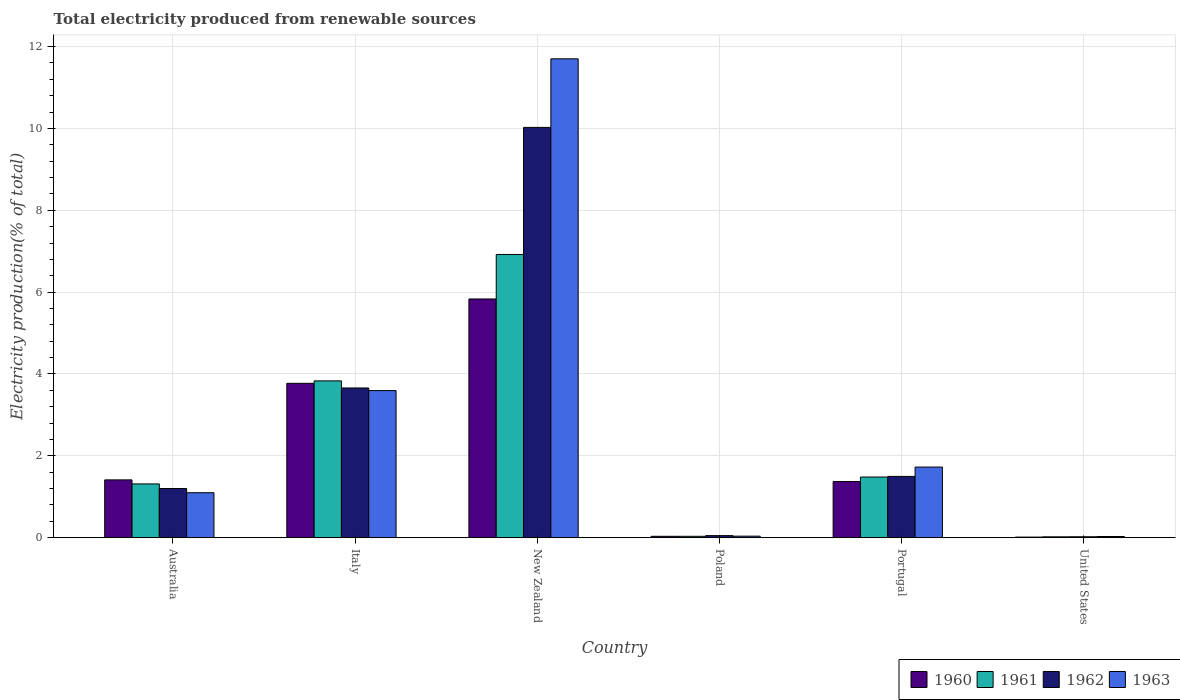How many different coloured bars are there?
Make the answer very short. 4. What is the label of the 3rd group of bars from the left?
Offer a terse response. New Zealand. What is the total electricity produced in 1961 in Italy?
Offer a terse response. 3.83. Across all countries, what is the maximum total electricity produced in 1962?
Your response must be concise. 10.02. Across all countries, what is the minimum total electricity produced in 1960?
Offer a very short reply. 0.02. In which country was the total electricity produced in 1960 maximum?
Offer a terse response. New Zealand. What is the total total electricity produced in 1960 in the graph?
Offer a very short reply. 12.44. What is the difference between the total electricity produced in 1961 in Poland and that in Portugal?
Your response must be concise. -1.45. What is the difference between the total electricity produced in 1961 in Poland and the total electricity produced in 1962 in United States?
Make the answer very short. 0.01. What is the average total electricity produced in 1961 per country?
Make the answer very short. 2.27. What is the difference between the total electricity produced of/in 1961 and total electricity produced of/in 1963 in New Zealand?
Provide a succinct answer. -4.78. In how many countries, is the total electricity produced in 1962 greater than 0.4 %?
Ensure brevity in your answer.  4. What is the ratio of the total electricity produced in 1962 in Poland to that in Portugal?
Offer a terse response. 0.03. Is the total electricity produced in 1960 in Poland less than that in United States?
Provide a succinct answer. No. What is the difference between the highest and the second highest total electricity produced in 1960?
Your response must be concise. -2.36. What is the difference between the highest and the lowest total electricity produced in 1962?
Make the answer very short. 10. What does the 1st bar from the right in Australia represents?
Offer a terse response. 1963. Is it the case that in every country, the sum of the total electricity produced in 1961 and total electricity produced in 1960 is greater than the total electricity produced in 1962?
Give a very brief answer. Yes. How many bars are there?
Keep it short and to the point. 24. Are all the bars in the graph horizontal?
Provide a succinct answer. No. How many countries are there in the graph?
Give a very brief answer. 6. What is the difference between two consecutive major ticks on the Y-axis?
Offer a terse response. 2. Does the graph contain grids?
Provide a succinct answer. Yes. How many legend labels are there?
Offer a very short reply. 4. What is the title of the graph?
Provide a short and direct response. Total electricity produced from renewable sources. What is the label or title of the Y-axis?
Provide a short and direct response. Electricity production(% of total). What is the Electricity production(% of total) of 1960 in Australia?
Provide a short and direct response. 1.41. What is the Electricity production(% of total) of 1961 in Australia?
Provide a succinct answer. 1.31. What is the Electricity production(% of total) of 1962 in Australia?
Keep it short and to the point. 1.2. What is the Electricity production(% of total) in 1963 in Australia?
Provide a short and direct response. 1.1. What is the Electricity production(% of total) of 1960 in Italy?
Ensure brevity in your answer.  3.77. What is the Electricity production(% of total) in 1961 in Italy?
Provide a short and direct response. 3.83. What is the Electricity production(% of total) of 1962 in Italy?
Give a very brief answer. 3.66. What is the Electricity production(% of total) in 1963 in Italy?
Offer a terse response. 3.59. What is the Electricity production(% of total) of 1960 in New Zealand?
Keep it short and to the point. 5.83. What is the Electricity production(% of total) in 1961 in New Zealand?
Your answer should be very brief. 6.92. What is the Electricity production(% of total) of 1962 in New Zealand?
Your answer should be very brief. 10.02. What is the Electricity production(% of total) of 1963 in New Zealand?
Ensure brevity in your answer.  11.7. What is the Electricity production(% of total) in 1960 in Poland?
Offer a very short reply. 0.03. What is the Electricity production(% of total) in 1961 in Poland?
Your response must be concise. 0.03. What is the Electricity production(% of total) in 1962 in Poland?
Make the answer very short. 0.05. What is the Electricity production(% of total) of 1963 in Poland?
Give a very brief answer. 0.04. What is the Electricity production(% of total) in 1960 in Portugal?
Your answer should be compact. 1.37. What is the Electricity production(% of total) of 1961 in Portugal?
Offer a terse response. 1.48. What is the Electricity production(% of total) in 1962 in Portugal?
Provide a short and direct response. 1.5. What is the Electricity production(% of total) of 1963 in Portugal?
Provide a short and direct response. 1.73. What is the Electricity production(% of total) of 1960 in United States?
Make the answer very short. 0.02. What is the Electricity production(% of total) in 1961 in United States?
Provide a succinct answer. 0.02. What is the Electricity production(% of total) in 1962 in United States?
Offer a terse response. 0.02. What is the Electricity production(% of total) of 1963 in United States?
Make the answer very short. 0.03. Across all countries, what is the maximum Electricity production(% of total) of 1960?
Provide a short and direct response. 5.83. Across all countries, what is the maximum Electricity production(% of total) of 1961?
Offer a very short reply. 6.92. Across all countries, what is the maximum Electricity production(% of total) in 1962?
Offer a very short reply. 10.02. Across all countries, what is the maximum Electricity production(% of total) in 1963?
Offer a terse response. 11.7. Across all countries, what is the minimum Electricity production(% of total) of 1960?
Your answer should be very brief. 0.02. Across all countries, what is the minimum Electricity production(% of total) in 1961?
Your response must be concise. 0.02. Across all countries, what is the minimum Electricity production(% of total) in 1962?
Offer a terse response. 0.02. Across all countries, what is the minimum Electricity production(% of total) in 1963?
Ensure brevity in your answer.  0.03. What is the total Electricity production(% of total) of 1960 in the graph?
Provide a succinct answer. 12.44. What is the total Electricity production(% of total) of 1961 in the graph?
Give a very brief answer. 13.6. What is the total Electricity production(% of total) of 1962 in the graph?
Offer a very short reply. 16.46. What is the total Electricity production(% of total) of 1963 in the graph?
Your answer should be very brief. 18.19. What is the difference between the Electricity production(% of total) in 1960 in Australia and that in Italy?
Your response must be concise. -2.36. What is the difference between the Electricity production(% of total) in 1961 in Australia and that in Italy?
Make the answer very short. -2.52. What is the difference between the Electricity production(% of total) of 1962 in Australia and that in Italy?
Offer a very short reply. -2.46. What is the difference between the Electricity production(% of total) of 1963 in Australia and that in Italy?
Offer a terse response. -2.5. What is the difference between the Electricity production(% of total) in 1960 in Australia and that in New Zealand?
Offer a terse response. -4.42. What is the difference between the Electricity production(% of total) in 1961 in Australia and that in New Zealand?
Offer a very short reply. -5.61. What is the difference between the Electricity production(% of total) in 1962 in Australia and that in New Zealand?
Offer a terse response. -8.82. What is the difference between the Electricity production(% of total) of 1963 in Australia and that in New Zealand?
Offer a very short reply. -10.6. What is the difference between the Electricity production(% of total) in 1960 in Australia and that in Poland?
Your answer should be very brief. 1.38. What is the difference between the Electricity production(% of total) of 1961 in Australia and that in Poland?
Your answer should be compact. 1.28. What is the difference between the Electricity production(% of total) of 1962 in Australia and that in Poland?
Provide a short and direct response. 1.15. What is the difference between the Electricity production(% of total) of 1963 in Australia and that in Poland?
Provide a succinct answer. 1.06. What is the difference between the Electricity production(% of total) in 1960 in Australia and that in Portugal?
Offer a terse response. 0.04. What is the difference between the Electricity production(% of total) in 1961 in Australia and that in Portugal?
Provide a short and direct response. -0.17. What is the difference between the Electricity production(% of total) in 1962 in Australia and that in Portugal?
Your response must be concise. -0.3. What is the difference between the Electricity production(% of total) of 1963 in Australia and that in Portugal?
Ensure brevity in your answer.  -0.63. What is the difference between the Electricity production(% of total) of 1960 in Australia and that in United States?
Your answer should be compact. 1.4. What is the difference between the Electricity production(% of total) in 1961 in Australia and that in United States?
Your response must be concise. 1.29. What is the difference between the Electricity production(% of total) in 1962 in Australia and that in United States?
Keep it short and to the point. 1.18. What is the difference between the Electricity production(% of total) of 1963 in Australia and that in United States?
Provide a succinct answer. 1.07. What is the difference between the Electricity production(% of total) in 1960 in Italy and that in New Zealand?
Your answer should be very brief. -2.06. What is the difference between the Electricity production(% of total) in 1961 in Italy and that in New Zealand?
Your answer should be very brief. -3.09. What is the difference between the Electricity production(% of total) in 1962 in Italy and that in New Zealand?
Make the answer very short. -6.37. What is the difference between the Electricity production(% of total) of 1963 in Italy and that in New Zealand?
Your response must be concise. -8.11. What is the difference between the Electricity production(% of total) of 1960 in Italy and that in Poland?
Give a very brief answer. 3.74. What is the difference between the Electricity production(% of total) of 1961 in Italy and that in Poland?
Your answer should be compact. 3.8. What is the difference between the Electricity production(% of total) in 1962 in Italy and that in Poland?
Provide a short and direct response. 3.61. What is the difference between the Electricity production(% of total) in 1963 in Italy and that in Poland?
Offer a terse response. 3.56. What is the difference between the Electricity production(% of total) in 1960 in Italy and that in Portugal?
Make the answer very short. 2.4. What is the difference between the Electricity production(% of total) of 1961 in Italy and that in Portugal?
Keep it short and to the point. 2.35. What is the difference between the Electricity production(% of total) of 1962 in Italy and that in Portugal?
Provide a short and direct response. 2.16. What is the difference between the Electricity production(% of total) in 1963 in Italy and that in Portugal?
Keep it short and to the point. 1.87. What is the difference between the Electricity production(% of total) of 1960 in Italy and that in United States?
Provide a short and direct response. 3.76. What is the difference between the Electricity production(% of total) in 1961 in Italy and that in United States?
Keep it short and to the point. 3.81. What is the difference between the Electricity production(% of total) of 1962 in Italy and that in United States?
Provide a short and direct response. 3.64. What is the difference between the Electricity production(% of total) of 1963 in Italy and that in United States?
Keep it short and to the point. 3.56. What is the difference between the Electricity production(% of total) of 1960 in New Zealand and that in Poland?
Offer a terse response. 5.8. What is the difference between the Electricity production(% of total) of 1961 in New Zealand and that in Poland?
Make the answer very short. 6.89. What is the difference between the Electricity production(% of total) in 1962 in New Zealand and that in Poland?
Your response must be concise. 9.97. What is the difference between the Electricity production(% of total) in 1963 in New Zealand and that in Poland?
Provide a short and direct response. 11.66. What is the difference between the Electricity production(% of total) of 1960 in New Zealand and that in Portugal?
Provide a succinct answer. 4.46. What is the difference between the Electricity production(% of total) in 1961 in New Zealand and that in Portugal?
Your answer should be compact. 5.44. What is the difference between the Electricity production(% of total) in 1962 in New Zealand and that in Portugal?
Give a very brief answer. 8.53. What is the difference between the Electricity production(% of total) in 1963 in New Zealand and that in Portugal?
Your answer should be compact. 9.97. What is the difference between the Electricity production(% of total) of 1960 in New Zealand and that in United States?
Provide a short and direct response. 5.82. What is the difference between the Electricity production(% of total) in 1961 in New Zealand and that in United States?
Offer a terse response. 6.9. What is the difference between the Electricity production(% of total) of 1962 in New Zealand and that in United States?
Keep it short and to the point. 10. What is the difference between the Electricity production(% of total) of 1963 in New Zealand and that in United States?
Give a very brief answer. 11.67. What is the difference between the Electricity production(% of total) in 1960 in Poland and that in Portugal?
Your response must be concise. -1.34. What is the difference between the Electricity production(% of total) in 1961 in Poland and that in Portugal?
Offer a very short reply. -1.45. What is the difference between the Electricity production(% of total) in 1962 in Poland and that in Portugal?
Provide a succinct answer. -1.45. What is the difference between the Electricity production(% of total) in 1963 in Poland and that in Portugal?
Your answer should be compact. -1.69. What is the difference between the Electricity production(% of total) in 1960 in Poland and that in United States?
Offer a terse response. 0.02. What is the difference between the Electricity production(% of total) in 1961 in Poland and that in United States?
Offer a very short reply. 0.01. What is the difference between the Electricity production(% of total) of 1962 in Poland and that in United States?
Provide a succinct answer. 0.03. What is the difference between the Electricity production(% of total) of 1963 in Poland and that in United States?
Keep it short and to the point. 0.01. What is the difference between the Electricity production(% of total) in 1960 in Portugal and that in United States?
Your answer should be very brief. 1.36. What is the difference between the Electricity production(% of total) in 1961 in Portugal and that in United States?
Ensure brevity in your answer.  1.46. What is the difference between the Electricity production(% of total) in 1962 in Portugal and that in United States?
Provide a succinct answer. 1.48. What is the difference between the Electricity production(% of total) of 1963 in Portugal and that in United States?
Give a very brief answer. 1.7. What is the difference between the Electricity production(% of total) of 1960 in Australia and the Electricity production(% of total) of 1961 in Italy?
Offer a terse response. -2.42. What is the difference between the Electricity production(% of total) in 1960 in Australia and the Electricity production(% of total) in 1962 in Italy?
Make the answer very short. -2.25. What is the difference between the Electricity production(% of total) of 1960 in Australia and the Electricity production(% of total) of 1963 in Italy?
Your answer should be very brief. -2.18. What is the difference between the Electricity production(% of total) of 1961 in Australia and the Electricity production(% of total) of 1962 in Italy?
Your response must be concise. -2.34. What is the difference between the Electricity production(% of total) in 1961 in Australia and the Electricity production(% of total) in 1963 in Italy?
Keep it short and to the point. -2.28. What is the difference between the Electricity production(% of total) of 1962 in Australia and the Electricity production(% of total) of 1963 in Italy?
Offer a terse response. -2.39. What is the difference between the Electricity production(% of total) of 1960 in Australia and the Electricity production(% of total) of 1961 in New Zealand?
Keep it short and to the point. -5.51. What is the difference between the Electricity production(% of total) in 1960 in Australia and the Electricity production(% of total) in 1962 in New Zealand?
Provide a short and direct response. -8.61. What is the difference between the Electricity production(% of total) of 1960 in Australia and the Electricity production(% of total) of 1963 in New Zealand?
Your answer should be very brief. -10.29. What is the difference between the Electricity production(% of total) of 1961 in Australia and the Electricity production(% of total) of 1962 in New Zealand?
Make the answer very short. -8.71. What is the difference between the Electricity production(% of total) of 1961 in Australia and the Electricity production(% of total) of 1963 in New Zealand?
Offer a very short reply. -10.39. What is the difference between the Electricity production(% of total) of 1962 in Australia and the Electricity production(% of total) of 1963 in New Zealand?
Your response must be concise. -10.5. What is the difference between the Electricity production(% of total) in 1960 in Australia and the Electricity production(% of total) in 1961 in Poland?
Provide a succinct answer. 1.38. What is the difference between the Electricity production(% of total) in 1960 in Australia and the Electricity production(% of total) in 1962 in Poland?
Your answer should be compact. 1.36. What is the difference between the Electricity production(% of total) of 1960 in Australia and the Electricity production(% of total) of 1963 in Poland?
Ensure brevity in your answer.  1.37. What is the difference between the Electricity production(% of total) in 1961 in Australia and the Electricity production(% of total) in 1962 in Poland?
Offer a very short reply. 1.26. What is the difference between the Electricity production(% of total) in 1961 in Australia and the Electricity production(% of total) in 1963 in Poland?
Offer a very short reply. 1.28. What is the difference between the Electricity production(% of total) of 1962 in Australia and the Electricity production(% of total) of 1963 in Poland?
Offer a terse response. 1.16. What is the difference between the Electricity production(% of total) in 1960 in Australia and the Electricity production(% of total) in 1961 in Portugal?
Keep it short and to the point. -0.07. What is the difference between the Electricity production(% of total) in 1960 in Australia and the Electricity production(% of total) in 1962 in Portugal?
Ensure brevity in your answer.  -0.09. What is the difference between the Electricity production(% of total) of 1960 in Australia and the Electricity production(% of total) of 1963 in Portugal?
Your answer should be compact. -0.31. What is the difference between the Electricity production(% of total) in 1961 in Australia and the Electricity production(% of total) in 1962 in Portugal?
Offer a terse response. -0.18. What is the difference between the Electricity production(% of total) in 1961 in Australia and the Electricity production(% of total) in 1963 in Portugal?
Give a very brief answer. -0.41. What is the difference between the Electricity production(% of total) in 1962 in Australia and the Electricity production(% of total) in 1963 in Portugal?
Offer a terse response. -0.52. What is the difference between the Electricity production(% of total) in 1960 in Australia and the Electricity production(% of total) in 1961 in United States?
Your answer should be compact. 1.39. What is the difference between the Electricity production(% of total) of 1960 in Australia and the Electricity production(% of total) of 1962 in United States?
Provide a succinct answer. 1.39. What is the difference between the Electricity production(% of total) in 1960 in Australia and the Electricity production(% of total) in 1963 in United States?
Provide a succinct answer. 1.38. What is the difference between the Electricity production(% of total) in 1961 in Australia and the Electricity production(% of total) in 1962 in United States?
Keep it short and to the point. 1.29. What is the difference between the Electricity production(% of total) of 1961 in Australia and the Electricity production(% of total) of 1963 in United States?
Give a very brief answer. 1.28. What is the difference between the Electricity production(% of total) of 1962 in Australia and the Electricity production(% of total) of 1963 in United States?
Your answer should be very brief. 1.17. What is the difference between the Electricity production(% of total) in 1960 in Italy and the Electricity production(% of total) in 1961 in New Zealand?
Provide a short and direct response. -3.15. What is the difference between the Electricity production(% of total) in 1960 in Italy and the Electricity production(% of total) in 1962 in New Zealand?
Your response must be concise. -6.25. What is the difference between the Electricity production(% of total) of 1960 in Italy and the Electricity production(% of total) of 1963 in New Zealand?
Your response must be concise. -7.93. What is the difference between the Electricity production(% of total) in 1961 in Italy and the Electricity production(% of total) in 1962 in New Zealand?
Offer a very short reply. -6.19. What is the difference between the Electricity production(% of total) in 1961 in Italy and the Electricity production(% of total) in 1963 in New Zealand?
Give a very brief answer. -7.87. What is the difference between the Electricity production(% of total) in 1962 in Italy and the Electricity production(% of total) in 1963 in New Zealand?
Your answer should be compact. -8.04. What is the difference between the Electricity production(% of total) of 1960 in Italy and the Electricity production(% of total) of 1961 in Poland?
Your answer should be very brief. 3.74. What is the difference between the Electricity production(% of total) in 1960 in Italy and the Electricity production(% of total) in 1962 in Poland?
Your response must be concise. 3.72. What is the difference between the Electricity production(% of total) of 1960 in Italy and the Electricity production(% of total) of 1963 in Poland?
Make the answer very short. 3.73. What is the difference between the Electricity production(% of total) in 1961 in Italy and the Electricity production(% of total) in 1962 in Poland?
Offer a very short reply. 3.78. What is the difference between the Electricity production(% of total) in 1961 in Italy and the Electricity production(% of total) in 1963 in Poland?
Ensure brevity in your answer.  3.79. What is the difference between the Electricity production(% of total) of 1962 in Italy and the Electricity production(% of total) of 1963 in Poland?
Keep it short and to the point. 3.62. What is the difference between the Electricity production(% of total) in 1960 in Italy and the Electricity production(% of total) in 1961 in Portugal?
Offer a very short reply. 2.29. What is the difference between the Electricity production(% of total) of 1960 in Italy and the Electricity production(% of total) of 1962 in Portugal?
Offer a very short reply. 2.27. What is the difference between the Electricity production(% of total) of 1960 in Italy and the Electricity production(% of total) of 1963 in Portugal?
Make the answer very short. 2.05. What is the difference between the Electricity production(% of total) of 1961 in Italy and the Electricity production(% of total) of 1962 in Portugal?
Give a very brief answer. 2.33. What is the difference between the Electricity production(% of total) in 1961 in Italy and the Electricity production(% of total) in 1963 in Portugal?
Your response must be concise. 2.11. What is the difference between the Electricity production(% of total) of 1962 in Italy and the Electricity production(% of total) of 1963 in Portugal?
Ensure brevity in your answer.  1.93. What is the difference between the Electricity production(% of total) of 1960 in Italy and the Electricity production(% of total) of 1961 in United States?
Your response must be concise. 3.75. What is the difference between the Electricity production(% of total) of 1960 in Italy and the Electricity production(% of total) of 1962 in United States?
Make the answer very short. 3.75. What is the difference between the Electricity production(% of total) in 1960 in Italy and the Electricity production(% of total) in 1963 in United States?
Provide a succinct answer. 3.74. What is the difference between the Electricity production(% of total) in 1961 in Italy and the Electricity production(% of total) in 1962 in United States?
Your response must be concise. 3.81. What is the difference between the Electricity production(% of total) of 1961 in Italy and the Electricity production(% of total) of 1963 in United States?
Make the answer very short. 3.8. What is the difference between the Electricity production(% of total) in 1962 in Italy and the Electricity production(% of total) in 1963 in United States?
Make the answer very short. 3.63. What is the difference between the Electricity production(% of total) of 1960 in New Zealand and the Electricity production(% of total) of 1961 in Poland?
Give a very brief answer. 5.8. What is the difference between the Electricity production(% of total) of 1960 in New Zealand and the Electricity production(% of total) of 1962 in Poland?
Offer a terse response. 5.78. What is the difference between the Electricity production(% of total) in 1960 in New Zealand and the Electricity production(% of total) in 1963 in Poland?
Make the answer very short. 5.79. What is the difference between the Electricity production(% of total) in 1961 in New Zealand and the Electricity production(% of total) in 1962 in Poland?
Your answer should be very brief. 6.87. What is the difference between the Electricity production(% of total) of 1961 in New Zealand and the Electricity production(% of total) of 1963 in Poland?
Provide a short and direct response. 6.88. What is the difference between the Electricity production(% of total) in 1962 in New Zealand and the Electricity production(% of total) in 1963 in Poland?
Provide a short and direct response. 9.99. What is the difference between the Electricity production(% of total) of 1960 in New Zealand and the Electricity production(% of total) of 1961 in Portugal?
Provide a short and direct response. 4.35. What is the difference between the Electricity production(% of total) of 1960 in New Zealand and the Electricity production(% of total) of 1962 in Portugal?
Offer a very short reply. 4.33. What is the difference between the Electricity production(% of total) of 1960 in New Zealand and the Electricity production(% of total) of 1963 in Portugal?
Your answer should be very brief. 4.11. What is the difference between the Electricity production(% of total) of 1961 in New Zealand and the Electricity production(% of total) of 1962 in Portugal?
Your response must be concise. 5.42. What is the difference between the Electricity production(% of total) of 1961 in New Zealand and the Electricity production(% of total) of 1963 in Portugal?
Make the answer very short. 5.19. What is the difference between the Electricity production(% of total) in 1962 in New Zealand and the Electricity production(% of total) in 1963 in Portugal?
Give a very brief answer. 8.3. What is the difference between the Electricity production(% of total) in 1960 in New Zealand and the Electricity production(% of total) in 1961 in United States?
Provide a succinct answer. 5.81. What is the difference between the Electricity production(% of total) of 1960 in New Zealand and the Electricity production(% of total) of 1962 in United States?
Make the answer very short. 5.81. What is the difference between the Electricity production(% of total) of 1960 in New Zealand and the Electricity production(% of total) of 1963 in United States?
Give a very brief answer. 5.8. What is the difference between the Electricity production(% of total) of 1961 in New Zealand and the Electricity production(% of total) of 1962 in United States?
Ensure brevity in your answer.  6.9. What is the difference between the Electricity production(% of total) in 1961 in New Zealand and the Electricity production(% of total) in 1963 in United States?
Give a very brief answer. 6.89. What is the difference between the Electricity production(% of total) of 1962 in New Zealand and the Electricity production(% of total) of 1963 in United States?
Give a very brief answer. 10. What is the difference between the Electricity production(% of total) of 1960 in Poland and the Electricity production(% of total) of 1961 in Portugal?
Ensure brevity in your answer.  -1.45. What is the difference between the Electricity production(% of total) in 1960 in Poland and the Electricity production(% of total) in 1962 in Portugal?
Keep it short and to the point. -1.46. What is the difference between the Electricity production(% of total) in 1960 in Poland and the Electricity production(% of total) in 1963 in Portugal?
Provide a succinct answer. -1.69. What is the difference between the Electricity production(% of total) of 1961 in Poland and the Electricity production(% of total) of 1962 in Portugal?
Provide a succinct answer. -1.46. What is the difference between the Electricity production(% of total) of 1961 in Poland and the Electricity production(% of total) of 1963 in Portugal?
Offer a very short reply. -1.69. What is the difference between the Electricity production(% of total) in 1962 in Poland and the Electricity production(% of total) in 1963 in Portugal?
Offer a terse response. -1.67. What is the difference between the Electricity production(% of total) in 1960 in Poland and the Electricity production(% of total) in 1961 in United States?
Provide a succinct answer. 0.01. What is the difference between the Electricity production(% of total) in 1960 in Poland and the Electricity production(% of total) in 1962 in United States?
Offer a very short reply. 0.01. What is the difference between the Electricity production(% of total) of 1960 in Poland and the Electricity production(% of total) of 1963 in United States?
Ensure brevity in your answer.  0. What is the difference between the Electricity production(% of total) in 1961 in Poland and the Electricity production(% of total) in 1962 in United States?
Offer a terse response. 0.01. What is the difference between the Electricity production(% of total) in 1961 in Poland and the Electricity production(% of total) in 1963 in United States?
Give a very brief answer. 0. What is the difference between the Electricity production(% of total) of 1962 in Poland and the Electricity production(% of total) of 1963 in United States?
Your answer should be very brief. 0.02. What is the difference between the Electricity production(% of total) in 1960 in Portugal and the Electricity production(% of total) in 1961 in United States?
Provide a short and direct response. 1.35. What is the difference between the Electricity production(% of total) in 1960 in Portugal and the Electricity production(% of total) in 1962 in United States?
Your answer should be compact. 1.35. What is the difference between the Electricity production(% of total) of 1960 in Portugal and the Electricity production(% of total) of 1963 in United States?
Offer a very short reply. 1.34. What is the difference between the Electricity production(% of total) in 1961 in Portugal and the Electricity production(% of total) in 1962 in United States?
Offer a terse response. 1.46. What is the difference between the Electricity production(% of total) in 1961 in Portugal and the Electricity production(% of total) in 1963 in United States?
Provide a succinct answer. 1.45. What is the difference between the Electricity production(% of total) of 1962 in Portugal and the Electricity production(% of total) of 1963 in United States?
Your response must be concise. 1.47. What is the average Electricity production(% of total) of 1960 per country?
Keep it short and to the point. 2.07. What is the average Electricity production(% of total) in 1961 per country?
Make the answer very short. 2.27. What is the average Electricity production(% of total) in 1962 per country?
Offer a very short reply. 2.74. What is the average Electricity production(% of total) in 1963 per country?
Offer a very short reply. 3.03. What is the difference between the Electricity production(% of total) of 1960 and Electricity production(% of total) of 1961 in Australia?
Your response must be concise. 0.1. What is the difference between the Electricity production(% of total) of 1960 and Electricity production(% of total) of 1962 in Australia?
Provide a short and direct response. 0.21. What is the difference between the Electricity production(% of total) of 1960 and Electricity production(% of total) of 1963 in Australia?
Provide a short and direct response. 0.31. What is the difference between the Electricity production(% of total) in 1961 and Electricity production(% of total) in 1962 in Australia?
Your answer should be very brief. 0.11. What is the difference between the Electricity production(% of total) in 1961 and Electricity production(% of total) in 1963 in Australia?
Provide a succinct answer. 0.21. What is the difference between the Electricity production(% of total) of 1962 and Electricity production(% of total) of 1963 in Australia?
Provide a short and direct response. 0.1. What is the difference between the Electricity production(% of total) of 1960 and Electricity production(% of total) of 1961 in Italy?
Offer a terse response. -0.06. What is the difference between the Electricity production(% of total) of 1960 and Electricity production(% of total) of 1962 in Italy?
Keep it short and to the point. 0.11. What is the difference between the Electricity production(% of total) in 1960 and Electricity production(% of total) in 1963 in Italy?
Offer a very short reply. 0.18. What is the difference between the Electricity production(% of total) of 1961 and Electricity production(% of total) of 1962 in Italy?
Offer a very short reply. 0.17. What is the difference between the Electricity production(% of total) of 1961 and Electricity production(% of total) of 1963 in Italy?
Ensure brevity in your answer.  0.24. What is the difference between the Electricity production(% of total) in 1962 and Electricity production(% of total) in 1963 in Italy?
Make the answer very short. 0.06. What is the difference between the Electricity production(% of total) in 1960 and Electricity production(% of total) in 1961 in New Zealand?
Provide a succinct answer. -1.09. What is the difference between the Electricity production(% of total) of 1960 and Electricity production(% of total) of 1962 in New Zealand?
Your response must be concise. -4.19. What is the difference between the Electricity production(% of total) of 1960 and Electricity production(% of total) of 1963 in New Zealand?
Provide a succinct answer. -5.87. What is the difference between the Electricity production(% of total) in 1961 and Electricity production(% of total) in 1962 in New Zealand?
Give a very brief answer. -3.1. What is the difference between the Electricity production(% of total) of 1961 and Electricity production(% of total) of 1963 in New Zealand?
Your answer should be compact. -4.78. What is the difference between the Electricity production(% of total) of 1962 and Electricity production(% of total) of 1963 in New Zealand?
Make the answer very short. -1.68. What is the difference between the Electricity production(% of total) of 1960 and Electricity production(% of total) of 1962 in Poland?
Your answer should be very brief. -0.02. What is the difference between the Electricity production(% of total) of 1960 and Electricity production(% of total) of 1963 in Poland?
Keep it short and to the point. -0. What is the difference between the Electricity production(% of total) in 1961 and Electricity production(% of total) in 1962 in Poland?
Provide a succinct answer. -0.02. What is the difference between the Electricity production(% of total) in 1961 and Electricity production(% of total) in 1963 in Poland?
Provide a short and direct response. -0. What is the difference between the Electricity production(% of total) of 1962 and Electricity production(% of total) of 1963 in Poland?
Your response must be concise. 0.01. What is the difference between the Electricity production(% of total) in 1960 and Electricity production(% of total) in 1961 in Portugal?
Offer a terse response. -0.11. What is the difference between the Electricity production(% of total) of 1960 and Electricity production(% of total) of 1962 in Portugal?
Keep it short and to the point. -0.13. What is the difference between the Electricity production(% of total) in 1960 and Electricity production(% of total) in 1963 in Portugal?
Provide a succinct answer. -0.35. What is the difference between the Electricity production(% of total) of 1961 and Electricity production(% of total) of 1962 in Portugal?
Provide a short and direct response. -0.02. What is the difference between the Electricity production(% of total) of 1961 and Electricity production(% of total) of 1963 in Portugal?
Ensure brevity in your answer.  -0.24. What is the difference between the Electricity production(% of total) of 1962 and Electricity production(% of total) of 1963 in Portugal?
Offer a terse response. -0.23. What is the difference between the Electricity production(% of total) in 1960 and Electricity production(% of total) in 1961 in United States?
Offer a very short reply. -0.01. What is the difference between the Electricity production(% of total) in 1960 and Electricity production(% of total) in 1962 in United States?
Your answer should be compact. -0.01. What is the difference between the Electricity production(% of total) of 1960 and Electricity production(% of total) of 1963 in United States?
Provide a short and direct response. -0.01. What is the difference between the Electricity production(% of total) of 1961 and Electricity production(% of total) of 1962 in United States?
Offer a terse response. -0. What is the difference between the Electricity production(% of total) in 1961 and Electricity production(% of total) in 1963 in United States?
Keep it short and to the point. -0.01. What is the difference between the Electricity production(% of total) of 1962 and Electricity production(% of total) of 1963 in United States?
Provide a short and direct response. -0.01. What is the ratio of the Electricity production(% of total) in 1960 in Australia to that in Italy?
Your response must be concise. 0.37. What is the ratio of the Electricity production(% of total) of 1961 in Australia to that in Italy?
Offer a terse response. 0.34. What is the ratio of the Electricity production(% of total) of 1962 in Australia to that in Italy?
Give a very brief answer. 0.33. What is the ratio of the Electricity production(% of total) of 1963 in Australia to that in Italy?
Offer a very short reply. 0.31. What is the ratio of the Electricity production(% of total) of 1960 in Australia to that in New Zealand?
Make the answer very short. 0.24. What is the ratio of the Electricity production(% of total) of 1961 in Australia to that in New Zealand?
Your answer should be compact. 0.19. What is the ratio of the Electricity production(% of total) in 1962 in Australia to that in New Zealand?
Your response must be concise. 0.12. What is the ratio of the Electricity production(% of total) in 1963 in Australia to that in New Zealand?
Keep it short and to the point. 0.09. What is the ratio of the Electricity production(% of total) of 1960 in Australia to that in Poland?
Provide a succinct answer. 41.37. What is the ratio of the Electricity production(% of total) in 1961 in Australia to that in Poland?
Provide a succinct answer. 38.51. What is the ratio of the Electricity production(% of total) in 1962 in Australia to that in Poland?
Make the answer very short. 23.61. What is the ratio of the Electricity production(% of total) of 1963 in Australia to that in Poland?
Provide a short and direct response. 29. What is the ratio of the Electricity production(% of total) of 1960 in Australia to that in Portugal?
Ensure brevity in your answer.  1.03. What is the ratio of the Electricity production(% of total) in 1961 in Australia to that in Portugal?
Ensure brevity in your answer.  0.89. What is the ratio of the Electricity production(% of total) in 1962 in Australia to that in Portugal?
Provide a short and direct response. 0.8. What is the ratio of the Electricity production(% of total) in 1963 in Australia to that in Portugal?
Give a very brief answer. 0.64. What is the ratio of the Electricity production(% of total) of 1960 in Australia to that in United States?
Ensure brevity in your answer.  92.6. What is the ratio of the Electricity production(% of total) in 1961 in Australia to that in United States?
Your answer should be compact. 61. What is the ratio of the Electricity production(% of total) of 1962 in Australia to that in United States?
Your answer should be very brief. 52.74. What is the ratio of the Electricity production(% of total) in 1963 in Australia to that in United States?
Give a very brief answer. 37.34. What is the ratio of the Electricity production(% of total) of 1960 in Italy to that in New Zealand?
Your answer should be very brief. 0.65. What is the ratio of the Electricity production(% of total) in 1961 in Italy to that in New Zealand?
Make the answer very short. 0.55. What is the ratio of the Electricity production(% of total) in 1962 in Italy to that in New Zealand?
Offer a terse response. 0.36. What is the ratio of the Electricity production(% of total) of 1963 in Italy to that in New Zealand?
Give a very brief answer. 0.31. What is the ratio of the Electricity production(% of total) of 1960 in Italy to that in Poland?
Keep it short and to the point. 110.45. What is the ratio of the Electricity production(% of total) in 1961 in Italy to that in Poland?
Ensure brevity in your answer.  112.3. What is the ratio of the Electricity production(% of total) in 1962 in Italy to that in Poland?
Your answer should be compact. 71.88. What is the ratio of the Electricity production(% of total) in 1963 in Italy to that in Poland?
Your answer should be compact. 94.84. What is the ratio of the Electricity production(% of total) in 1960 in Italy to that in Portugal?
Ensure brevity in your answer.  2.75. What is the ratio of the Electricity production(% of total) in 1961 in Italy to that in Portugal?
Provide a succinct answer. 2.58. What is the ratio of the Electricity production(% of total) in 1962 in Italy to that in Portugal?
Give a very brief answer. 2.44. What is the ratio of the Electricity production(% of total) in 1963 in Italy to that in Portugal?
Your answer should be compact. 2.08. What is the ratio of the Electricity production(% of total) in 1960 in Italy to that in United States?
Provide a short and direct response. 247.25. What is the ratio of the Electricity production(% of total) in 1961 in Italy to that in United States?
Your response must be concise. 177.87. What is the ratio of the Electricity production(% of total) of 1962 in Italy to that in United States?
Provide a succinct answer. 160.56. What is the ratio of the Electricity production(% of total) of 1963 in Italy to that in United States?
Give a very brief answer. 122.12. What is the ratio of the Electricity production(% of total) in 1960 in New Zealand to that in Poland?
Your answer should be compact. 170.79. What is the ratio of the Electricity production(% of total) in 1961 in New Zealand to that in Poland?
Make the answer very short. 202.83. What is the ratio of the Electricity production(% of total) in 1962 in New Zealand to that in Poland?
Offer a terse response. 196.95. What is the ratio of the Electricity production(% of total) in 1963 in New Zealand to that in Poland?
Provide a succinct answer. 308.73. What is the ratio of the Electricity production(% of total) in 1960 in New Zealand to that in Portugal?
Offer a terse response. 4.25. What is the ratio of the Electricity production(% of total) in 1961 in New Zealand to that in Portugal?
Provide a succinct answer. 4.67. What is the ratio of the Electricity production(% of total) in 1962 in New Zealand to that in Portugal?
Your answer should be compact. 6.69. What is the ratio of the Electricity production(% of total) in 1963 in New Zealand to that in Portugal?
Keep it short and to the point. 6.78. What is the ratio of the Electricity production(% of total) of 1960 in New Zealand to that in United States?
Your answer should be compact. 382.31. What is the ratio of the Electricity production(% of total) in 1961 in New Zealand to that in United States?
Offer a very short reply. 321.25. What is the ratio of the Electricity production(% of total) of 1962 in New Zealand to that in United States?
Keep it short and to the point. 439.93. What is the ratio of the Electricity production(% of total) of 1963 in New Zealand to that in United States?
Provide a short and direct response. 397.5. What is the ratio of the Electricity production(% of total) of 1960 in Poland to that in Portugal?
Your answer should be very brief. 0.02. What is the ratio of the Electricity production(% of total) in 1961 in Poland to that in Portugal?
Make the answer very short. 0.02. What is the ratio of the Electricity production(% of total) of 1962 in Poland to that in Portugal?
Your answer should be very brief. 0.03. What is the ratio of the Electricity production(% of total) in 1963 in Poland to that in Portugal?
Your answer should be compact. 0.02. What is the ratio of the Electricity production(% of total) in 1960 in Poland to that in United States?
Your response must be concise. 2.24. What is the ratio of the Electricity production(% of total) of 1961 in Poland to that in United States?
Offer a terse response. 1.58. What is the ratio of the Electricity production(% of total) in 1962 in Poland to that in United States?
Your answer should be compact. 2.23. What is the ratio of the Electricity production(% of total) of 1963 in Poland to that in United States?
Offer a very short reply. 1.29. What is the ratio of the Electricity production(% of total) of 1960 in Portugal to that in United States?
Provide a succinct answer. 89.96. What is the ratio of the Electricity production(% of total) in 1961 in Portugal to that in United States?
Your answer should be very brief. 68.83. What is the ratio of the Electricity production(% of total) in 1962 in Portugal to that in United States?
Make the answer very short. 65.74. What is the ratio of the Electricity production(% of total) of 1963 in Portugal to that in United States?
Offer a terse response. 58.63. What is the difference between the highest and the second highest Electricity production(% of total) in 1960?
Make the answer very short. 2.06. What is the difference between the highest and the second highest Electricity production(% of total) in 1961?
Provide a short and direct response. 3.09. What is the difference between the highest and the second highest Electricity production(% of total) in 1962?
Keep it short and to the point. 6.37. What is the difference between the highest and the second highest Electricity production(% of total) in 1963?
Offer a terse response. 8.11. What is the difference between the highest and the lowest Electricity production(% of total) in 1960?
Give a very brief answer. 5.82. What is the difference between the highest and the lowest Electricity production(% of total) in 1961?
Your answer should be compact. 6.9. What is the difference between the highest and the lowest Electricity production(% of total) in 1962?
Offer a terse response. 10. What is the difference between the highest and the lowest Electricity production(% of total) of 1963?
Offer a terse response. 11.67. 